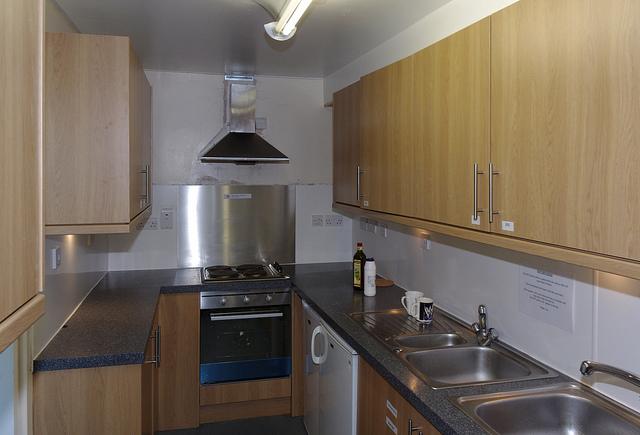Where is the oven?
Give a very brief answer. Back wall. Where are the two cups?
Keep it brief. On counter. Is this a clean kitchen?
Short answer required. Yes. 